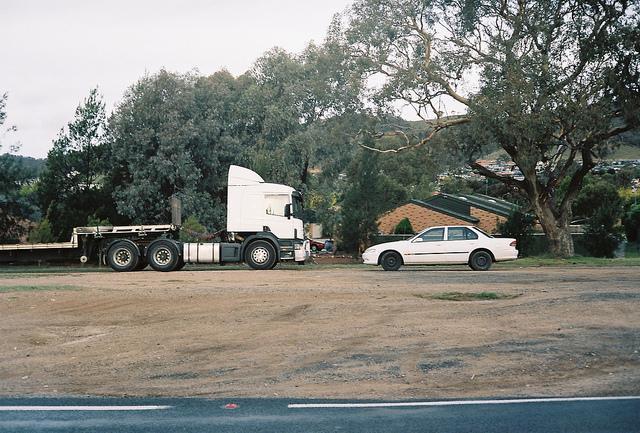How many wheels can be seen?
Give a very brief answer. 5. 